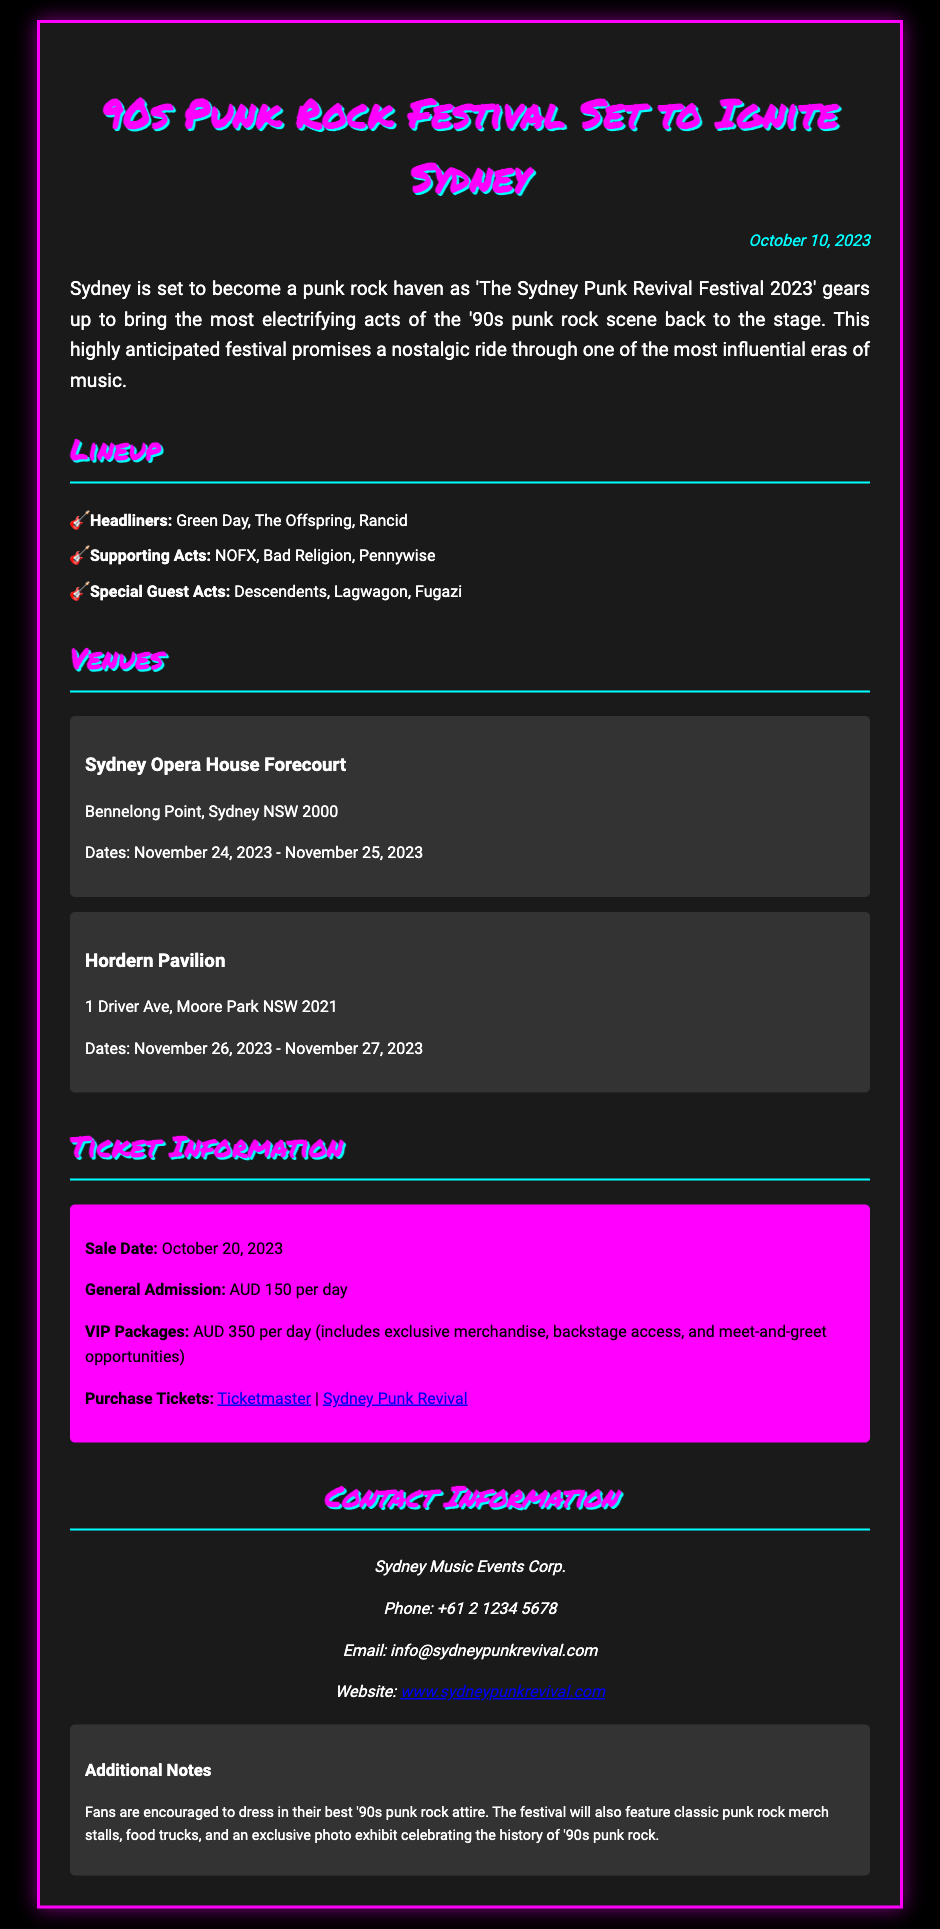What is the name of the festival? The name of the festival is stated in the title of the document.
Answer: The Sydney Punk Revival Festival 2023 When is the sale date for tickets? The sale date for tickets is mentioned in the Ticket Information section of the document.
Answer: October 20, 2023 How many days will the festival take place? The festival occurs over multiple days, as listed under the Venues section.
Answer: Four days Who are the headliners of the festival? The names of the headliners are provided in the Lineup section of the document.
Answer: Green Day, The Offspring, Rancid What is the price for a VIP package? The price for a VIP package is clearly indicated in the Ticket Information section.
Answer: AUD 350 per day Which venue will host the festival on November 26-27, 2023? The specific venue for those dates is detailed under the Venues section of the document.
Answer: Hordern Pavilion What should fans dress in for the festival? The document mentions recommendations for attire in the Additional Notes section.
Answer: '90s punk rock attire How can tickets be purchased? The methods for purchasing tickets are provided in the Ticket Information section.
Answer: Ticketmaster and Sydney Punk Revival 